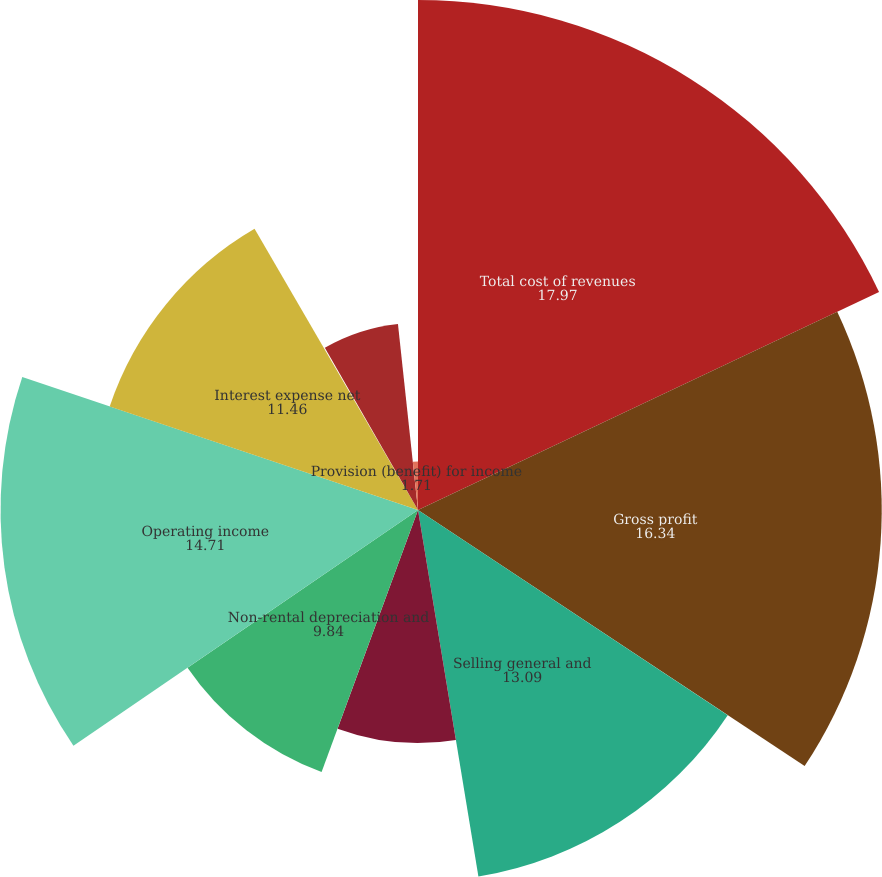Convert chart. <chart><loc_0><loc_0><loc_500><loc_500><pie_chart><fcel>Total cost of revenues<fcel>Gross profit<fcel>Selling general and<fcel>Restructuring charge<fcel>Non-rental depreciation and<fcel>Operating income<fcel>Interest expense net<fcel>Other income net<fcel>Income (loss) from continuing<fcel>Provision (benefit) for income<nl><fcel>17.97%<fcel>16.34%<fcel>13.09%<fcel>8.21%<fcel>9.84%<fcel>14.71%<fcel>11.46%<fcel>0.08%<fcel>6.59%<fcel>1.71%<nl></chart> 